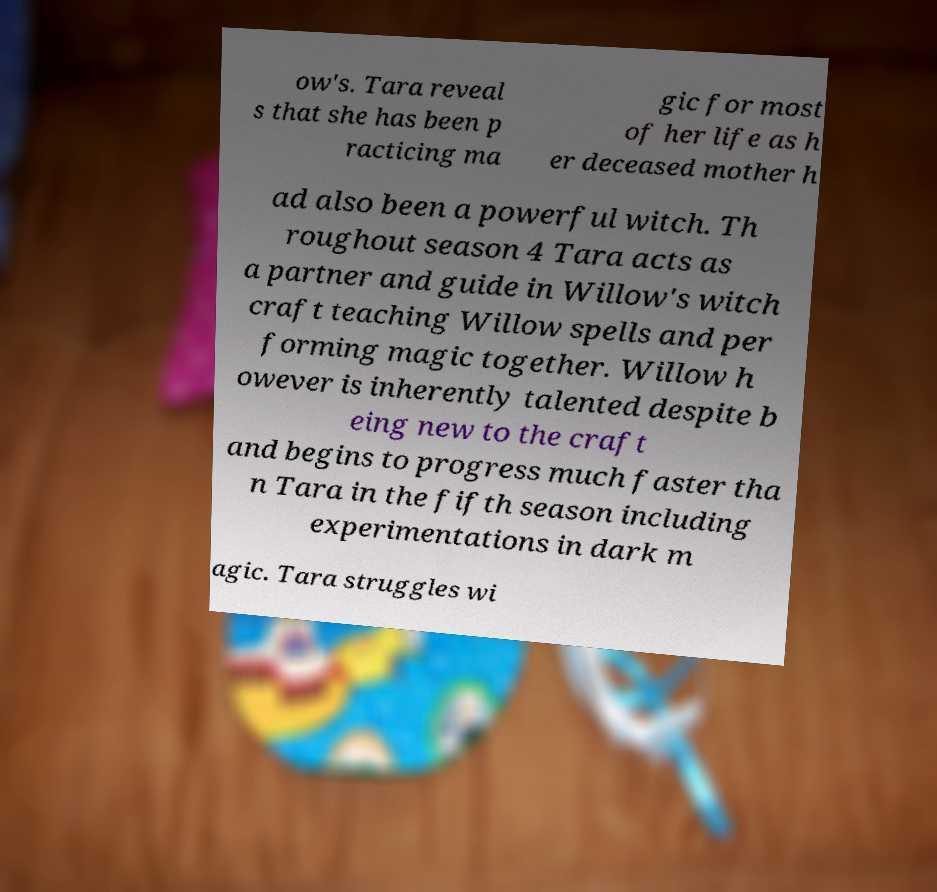What messages or text are displayed in this image? I need them in a readable, typed format. ow's. Tara reveal s that she has been p racticing ma gic for most of her life as h er deceased mother h ad also been a powerful witch. Th roughout season 4 Tara acts as a partner and guide in Willow's witch craft teaching Willow spells and per forming magic together. Willow h owever is inherently talented despite b eing new to the craft and begins to progress much faster tha n Tara in the fifth season including experimentations in dark m agic. Tara struggles wi 